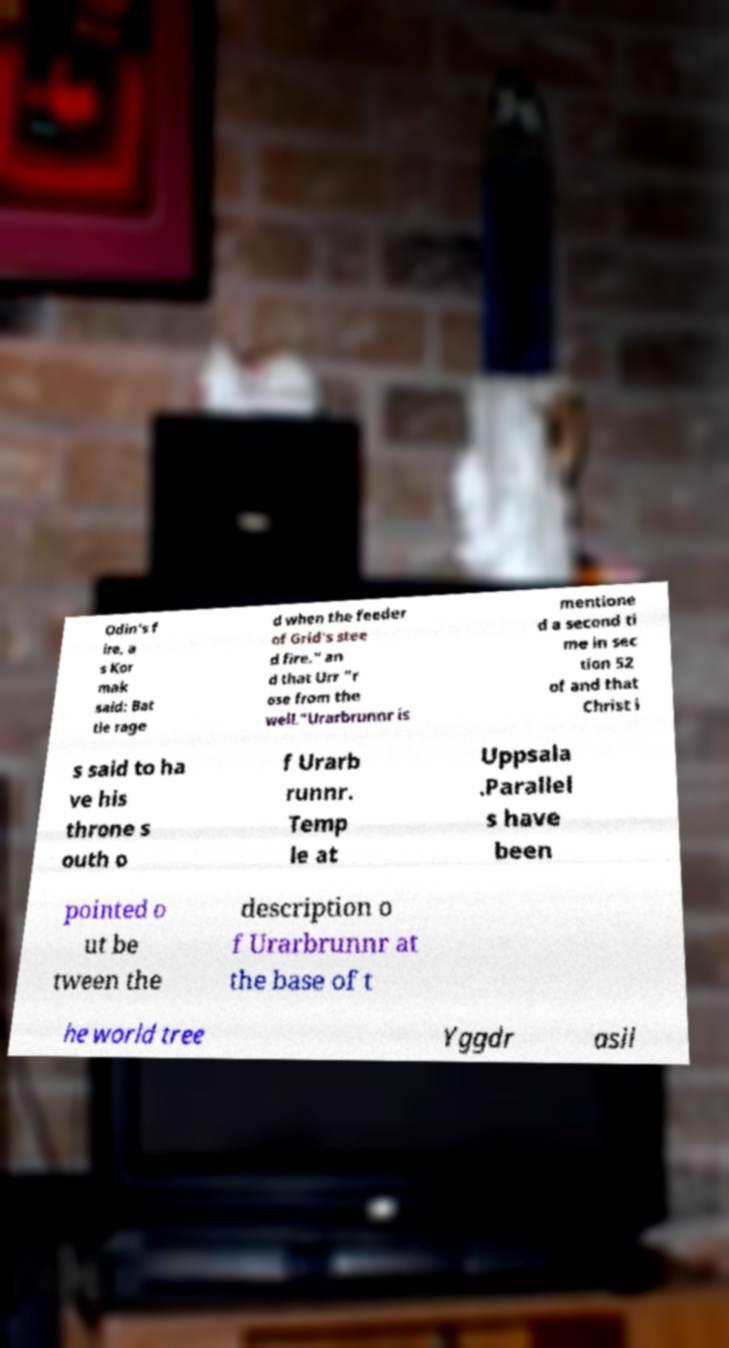Please identify and transcribe the text found in this image. Odin's f ire, a s Kor mak said: Bat tle rage d when the feeder of Grid's stee d fire." an d that Urr "r ose from the well."Urarbrunnr is mentione d a second ti me in sec tion 52 of and that Christ i s said to ha ve his throne s outh o f Urarb runnr. Temp le at Uppsala .Parallel s have been pointed o ut be tween the description o f Urarbrunnr at the base of t he world tree Yggdr asil 